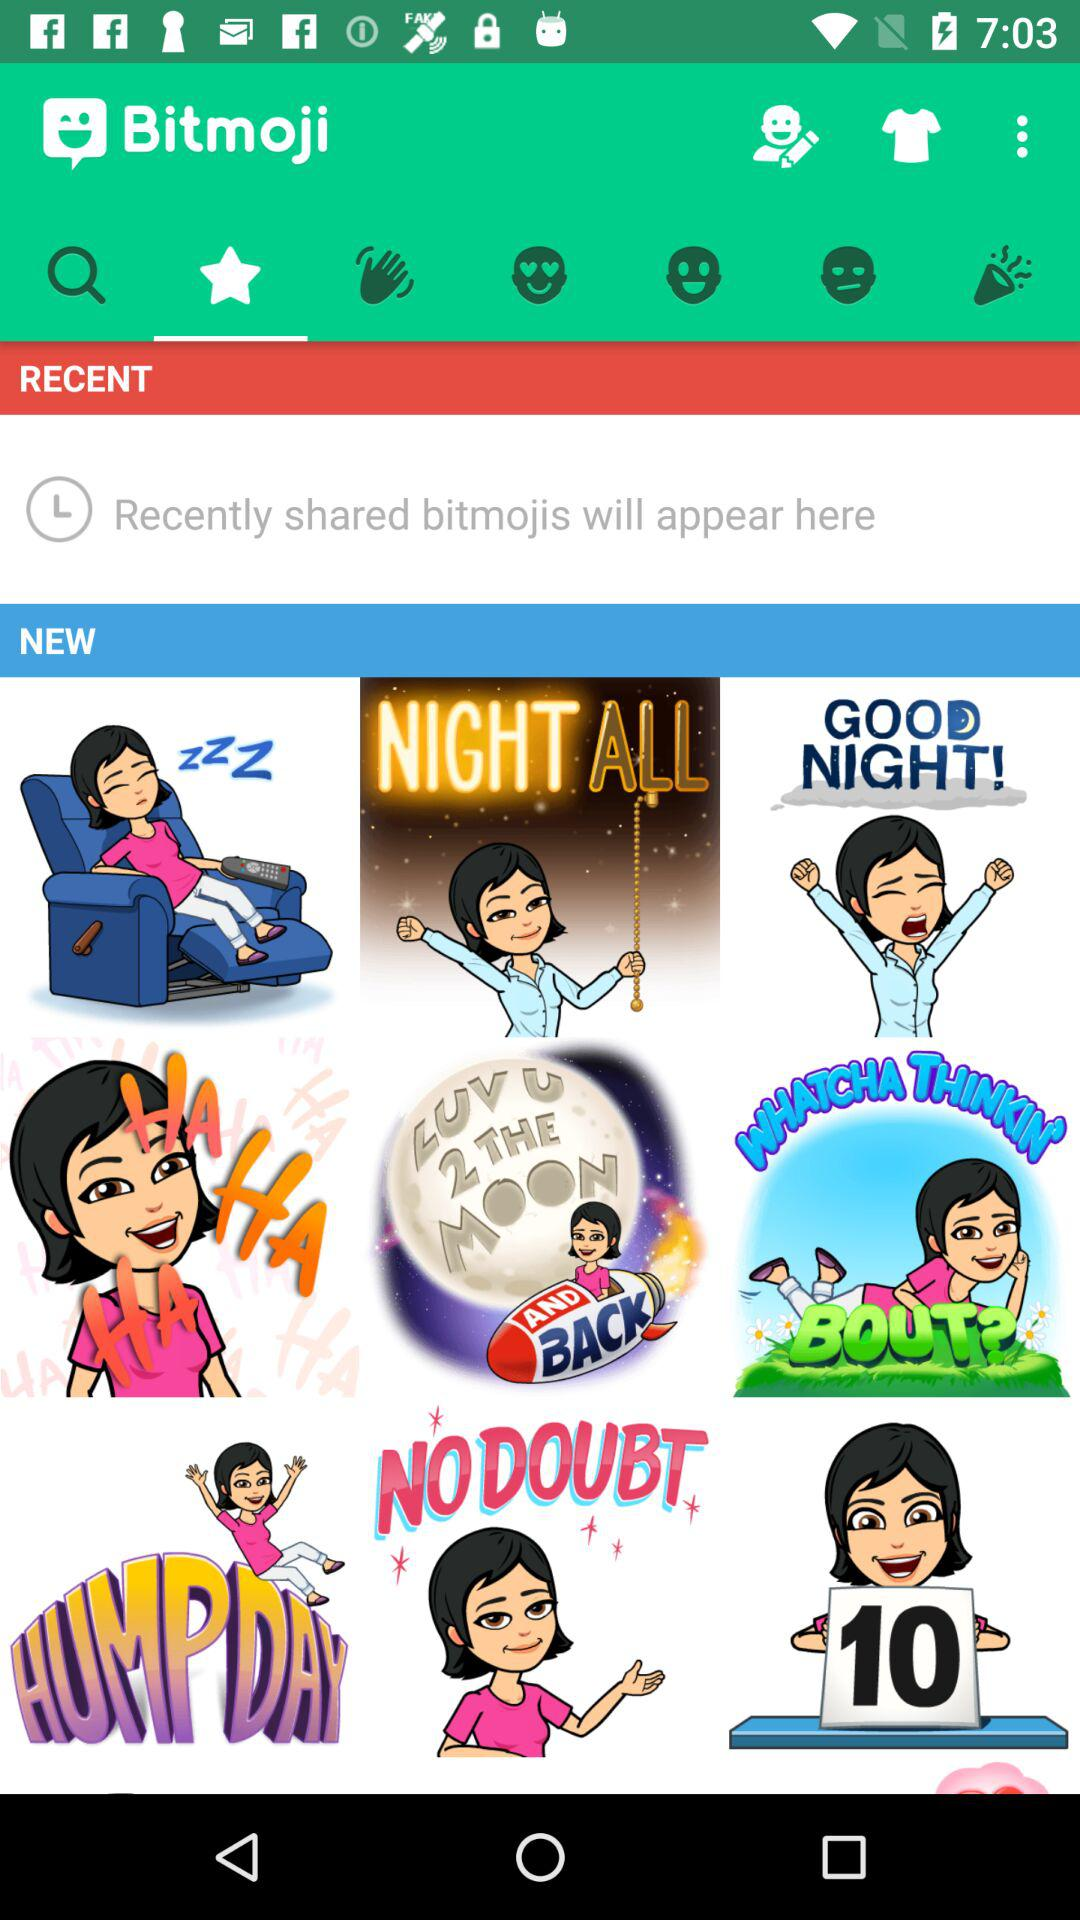What is the application name? The application name is "Bitmoji". 